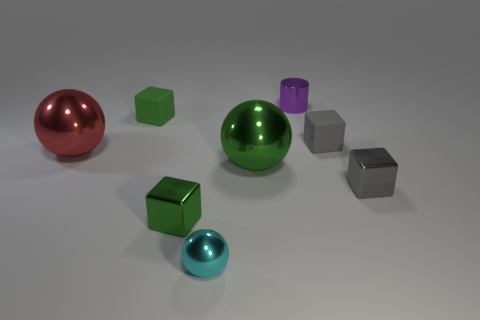Subtract all big metal spheres. How many spheres are left? 1 Subtract all green blocks. How many blocks are left? 2 Subtract 3 spheres. How many spheres are left? 0 Subtract 2 green blocks. How many objects are left? 6 Subtract all cylinders. How many objects are left? 7 Subtract all brown spheres. Subtract all blue blocks. How many spheres are left? 3 Subtract all gray cylinders. How many brown cubes are left? 0 Subtract all tiny green shiny blocks. Subtract all gray objects. How many objects are left? 5 Add 2 metallic things. How many metallic things are left? 8 Add 6 tiny gray matte objects. How many tiny gray matte objects exist? 7 